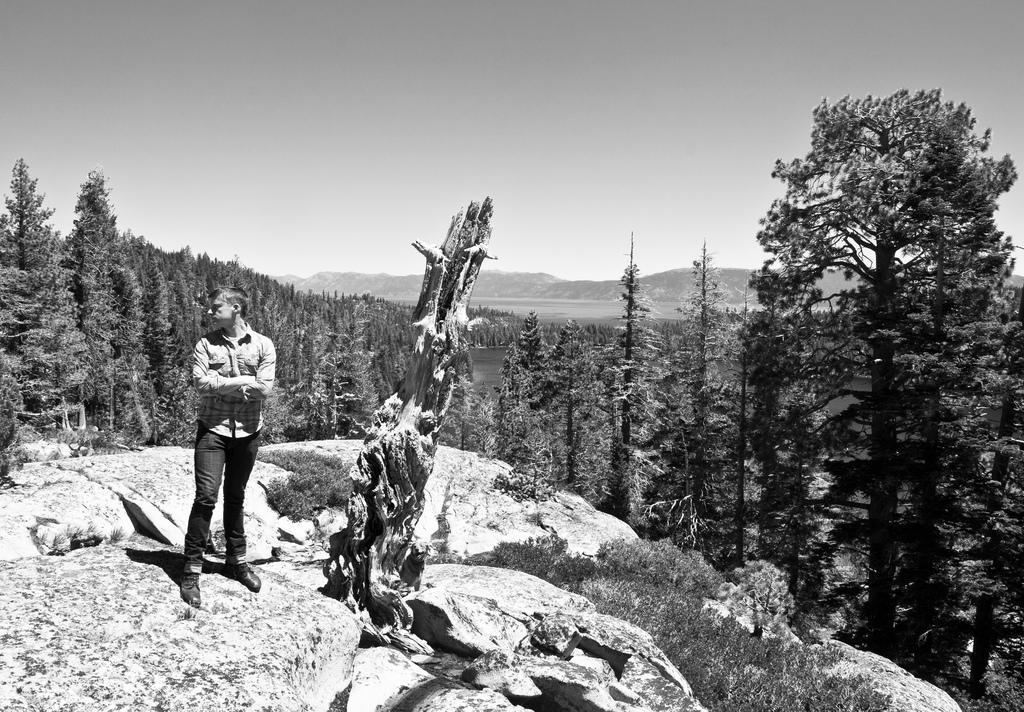Describe this image in one or two sentences. In this image I can see a person standing on the rock. Back I can see few trees and mountains. The image is in black and white. 